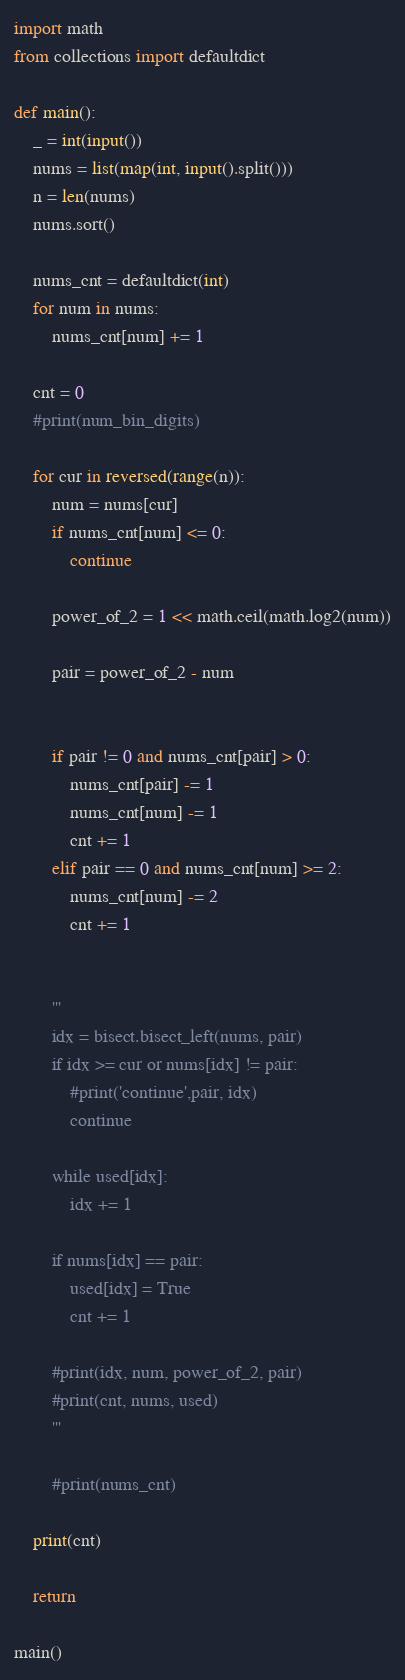Convert code to text. <code><loc_0><loc_0><loc_500><loc_500><_Python_>import math
from collections import defaultdict

def main():
    _ = int(input())
    nums = list(map(int, input().split()))
    n = len(nums)
    nums.sort()

    nums_cnt = defaultdict(int)
    for num in nums:
        nums_cnt[num] += 1

    cnt = 0
    #print(num_bin_digits)

    for cur in reversed(range(n)):
        num = nums[cur]
        if nums_cnt[num] <= 0:
            continue

        power_of_2 = 1 << math.ceil(math.log2(num))

        pair = power_of_2 - num


        if pair != 0 and nums_cnt[pair] > 0:
            nums_cnt[pair] -= 1
            nums_cnt[num] -= 1
            cnt += 1
        elif pair == 0 and nums_cnt[num] >= 2:
            nums_cnt[num] -= 2
            cnt += 1


        '''
        idx = bisect.bisect_left(nums, pair)
        if idx >= cur or nums[idx] != pair:
            #print('continue',pair, idx)
            continue

        while used[idx]:
            idx += 1

        if nums[idx] == pair:
            used[idx] = True
            cnt += 1

        #print(idx, num, power_of_2, pair)
        #print(cnt, nums, used)
        '''

        #print(nums_cnt)

    print(cnt)

    return

main()</code> 